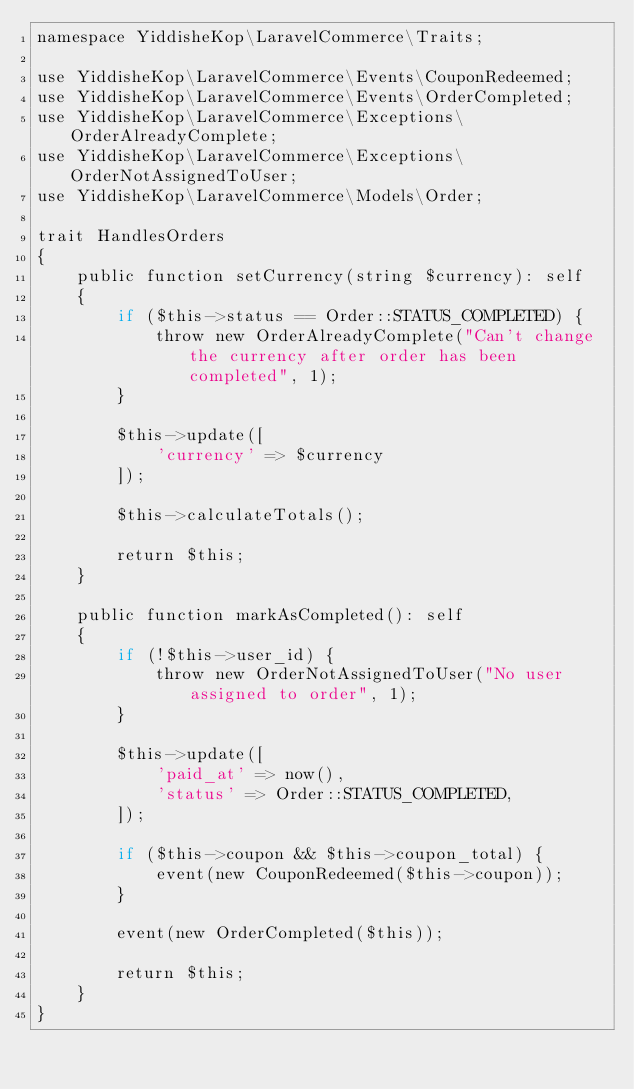<code> <loc_0><loc_0><loc_500><loc_500><_PHP_>namespace YiddisheKop\LaravelCommerce\Traits;

use YiddisheKop\LaravelCommerce\Events\CouponRedeemed;
use YiddisheKop\LaravelCommerce\Events\OrderCompleted;
use YiddisheKop\LaravelCommerce\Exceptions\OrderAlreadyComplete;
use YiddisheKop\LaravelCommerce\Exceptions\OrderNotAssignedToUser;
use YiddisheKop\LaravelCommerce\Models\Order;

trait HandlesOrders
{
    public function setCurrency(string $currency): self
    {
        if ($this->status == Order::STATUS_COMPLETED) {
            throw new OrderAlreadyComplete("Can't change the currency after order has been completed", 1);
        }

        $this->update([
            'currency' => $currency
        ]);

        $this->calculateTotals();

        return $this;
    }

    public function markAsCompleted(): self
    {
        if (!$this->user_id) {
            throw new OrderNotAssignedToUser("No user assigned to order", 1);
        }

        $this->update([
            'paid_at' => now(),
            'status' => Order::STATUS_COMPLETED,
        ]);

        if ($this->coupon && $this->coupon_total) {
            event(new CouponRedeemed($this->coupon));
        }

        event(new OrderCompleted($this));

        return $this;
    }
}
</code> 